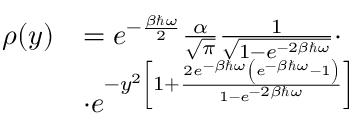<formula> <loc_0><loc_0><loc_500><loc_500>\begin{array} { r l } { \rho ( y ) } & { = e ^ { - \frac { \beta \hbar { \omega } } { 2 } } \frac { \alpha } { \sqrt { \pi } } \frac { 1 } { \sqrt { 1 - e ^ { - 2 \beta \hbar { \omega } } } } \cdot } \\ & { \cdot e ^ { - y ^ { 2 } \left [ 1 + \frac { 2 e ^ { - \beta \hbar { \omega } } \left ( e ^ { - \beta \hbar { \omega } } - 1 \right ) } { 1 - e ^ { - 2 \beta \hbar { \omega } } } \right ] } } \end{array}</formula> 